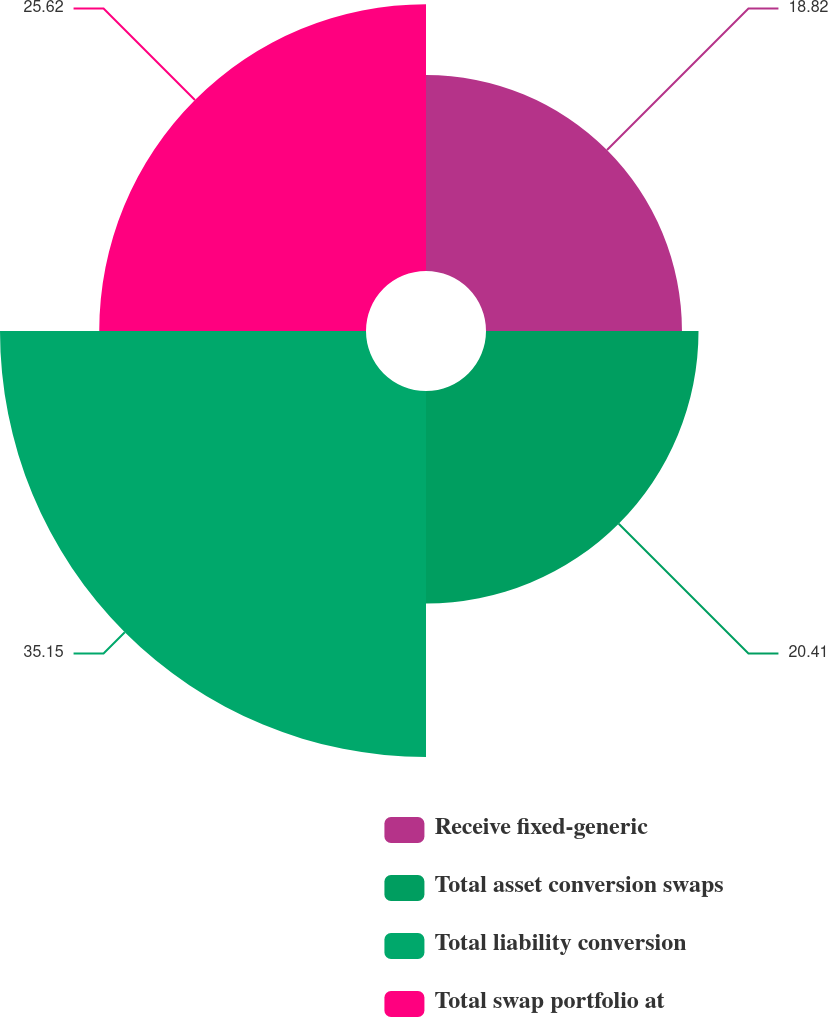Convert chart to OTSL. <chart><loc_0><loc_0><loc_500><loc_500><pie_chart><fcel>Receive fixed-generic<fcel>Total asset conversion swaps<fcel>Total liability conversion<fcel>Total swap portfolio at<nl><fcel>18.82%<fcel>20.41%<fcel>35.15%<fcel>25.62%<nl></chart> 